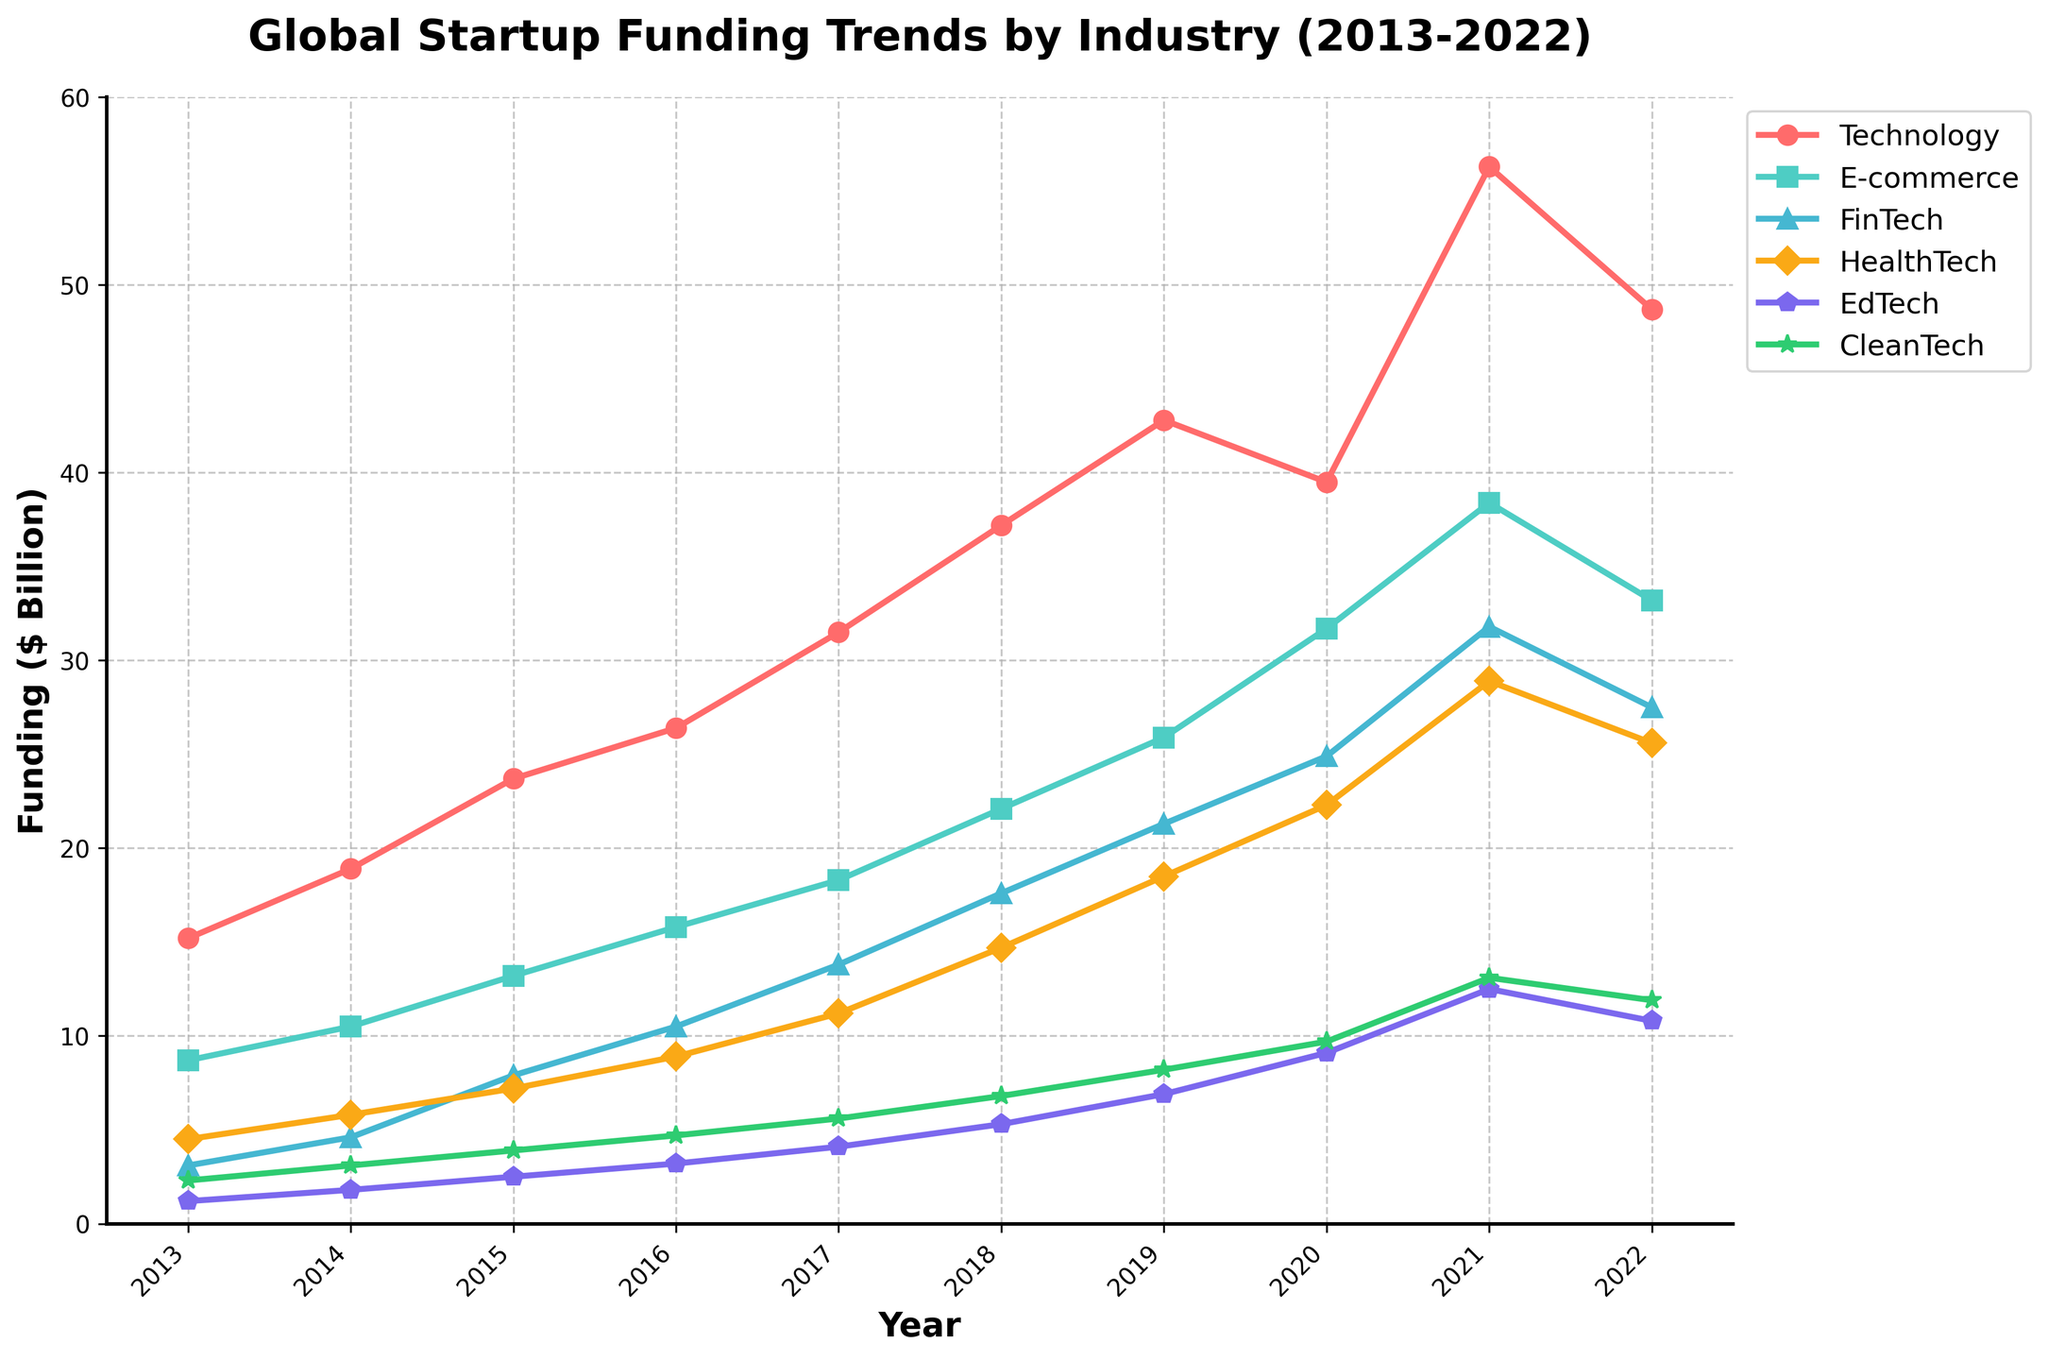What was the trend in global startup funding for the Technology sector from 2013 to 2022? To identify the trend, we need to observe the data points for the Technology sector across the years 2013 to 2022. The funding starts at 15.2 billion in 2013 and peaks at 56.3 billion in 2021 before slightly dropping to 48.7 billion in 2022. The overall trend is an upward trajectory with a small decline towards the end.
Answer: Upward with a small decline in 2022 Which sector had the highest funding in 2021, and what was the value? To find this, compare the funding amounts across all sectors for the year 2021. The Technology sector had the highest funding at 56.3 billion dollars.
Answer: Technology, 56.3 billion What is the difference in funding between the FinTech and HealthTech sectors in 2020? To calculate this, subtract the funding amount of HealthTech from that of FinTech in 2020: FinTech (24.9 billion) - HealthTech (22.3 billion) = 2.6 billion.
Answer: 2.6 billion How did the funding for CleanTech change from 2013 to 2021? Observe the funding amounts for CleanTech in 2013 and 2021 and describe the difference. In 2013, the funding was 2.3 billion, and by 2021 it had increased to 13.1 billion. This is an increase of 10.8 billion over the period.
Answer: Increased by 10.8 billion In which year did EdTech funding first surpass 10 billion dollars? Track the funding amounts for EdTech year by year and identify the first instance surpassing 10 billion. In 2020, EdTech funding was 12.5 billion, which is the first year it surpassed 10 billion.
Answer: 2020 Among the sectors shown, which experienced the most significant growth between 2013 and 2022? To determine this, calculate the difference in funding amounts from 2013 to 2022 for each sector. The Technology sector grew from 15.2 billion in 2013 to 48.7 billion in 2022, a growth of 33.5 billion, which is the largest among all the sectors.
Answer: Technology Compare the funding trends for HealthTech and CleanTech from 2017 to 2022. Analyze the funding amounts year by year for HealthTech and CleanTech between 2017 and 2022. HealthTech funding rose from 11.2 billion in 2017 to 25.6 billion in 2022, while CleanTech increased from 5.6 billion to 11.9 billion in the same period. Both sectors saw growth, but HealthTech had a more significant increase.
Answer: HealthTech saw more significant growth What is the average funding amount for EdTech over the decade? To find the average, sum the funding amounts for EdTech from 2013 to 2022 and divide by the number of years. The sum is 82.3 billion (4.5+5.8+7.2+8.9+11.2+14.7+18.5+22.3+28.9+25.6), and the average is 82.3/10 = 8.23 billion.
Answer: 8.23 billion Which two sectors had approximately equal funding in 2014, and what is the funding amount? Look at the funding amounts in 2014 and identify sectors with close values. E-commerce had 10.5 billion, and FinTech had 10.5 billion.
Answer: E-commerce and FinTech, 10.5 billion 